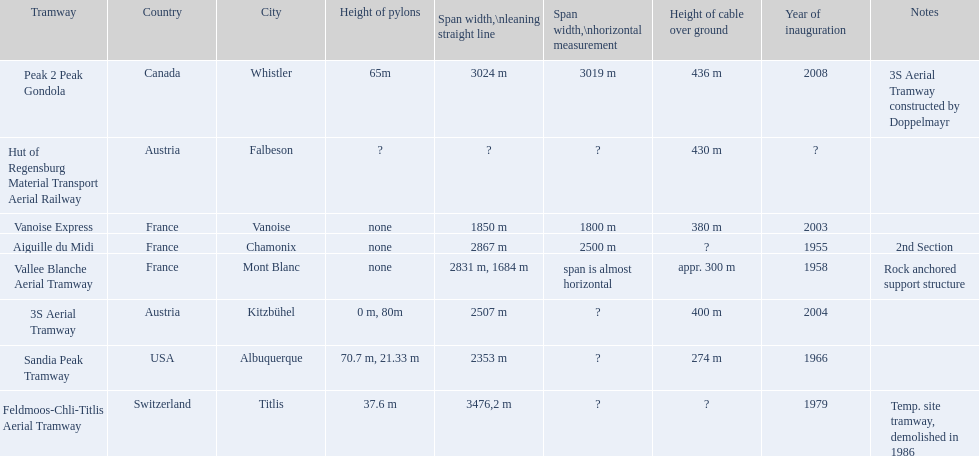What are the tramway systems located in france? Vanoise Express, Aiguille du Midi, Vallee Blanche Aerial Tramway. Which ones were established in the 1950s? Aiguille du Midi, Vallee Blanche Aerial Tramway. Are there any with spans that are not nearly horizontal? Aiguille du Midi. 